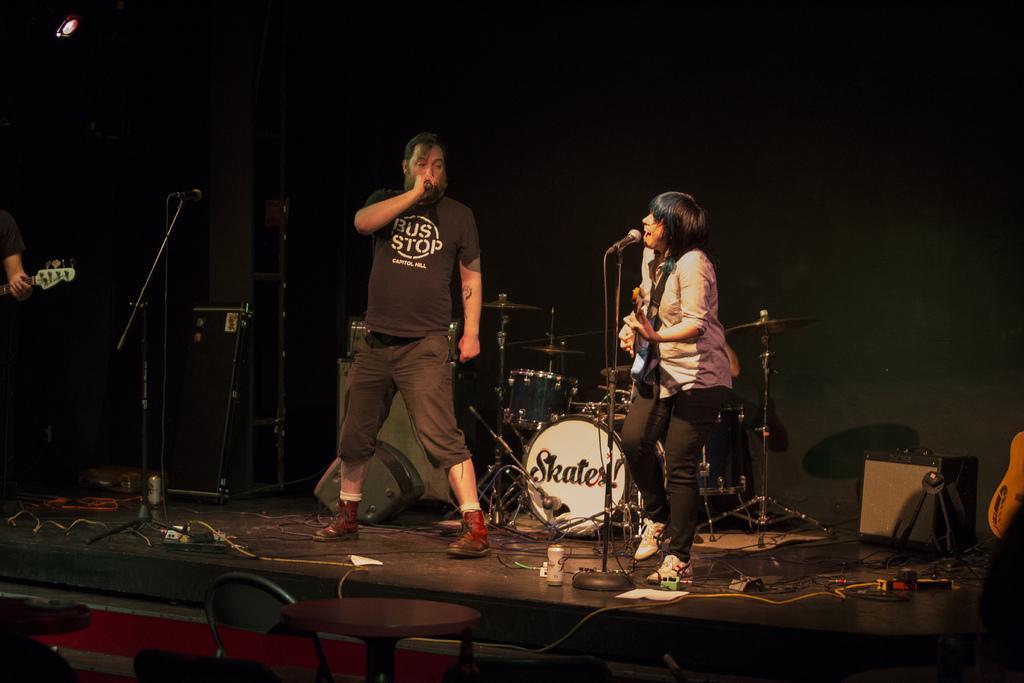Could you give a brief overview of what you see in this image? In this image we can see two persons standing on the stage. Here we can see a man. He is wearing a black color T-shirt and he is singing on a microphone. Here we can see a woman on the right side. She is playing a guitar and she is singing on a microphone. Here we can see another person holding the guitar and he is on the left side. In the background, we can see the snare drum musical arrangement on the stage. Here we can see the chairs at the bottom. 